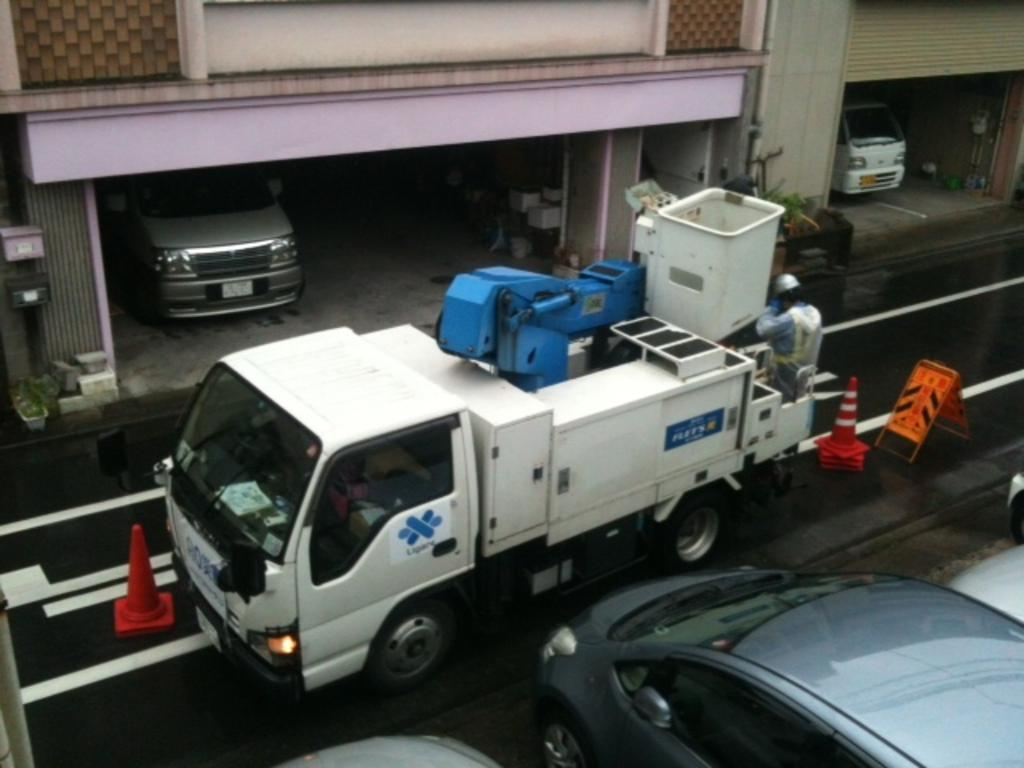What is the main feature of the image? There is a road in the image. What is happening on the road? Vehicles are present on the road. Can you describe the person in the image? There is a person in the image. What safety measure is visible in the image? Traffic cones are visible in the image. What can be seen in the background of the image? There are buildings in the background of the image. How many shoes can be seen on the person in the image? There is no person wearing shoes in the image; the person is not visible in the image. 